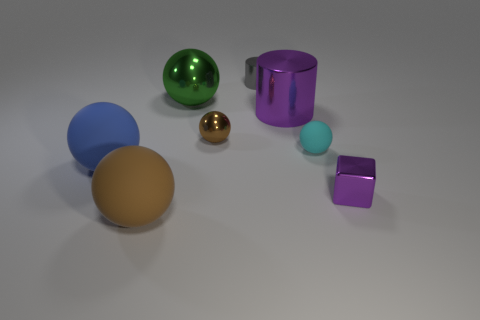How many big purple objects have the same shape as the cyan thing?
Offer a terse response. 0. The matte thing that is both behind the brown rubber sphere and left of the small brown shiny object is what color?
Your answer should be very brief. Blue. What number of cyan things are there?
Make the answer very short. 1. Does the block have the same size as the cyan matte object?
Offer a very short reply. Yes. Are there any other tiny shiny cylinders of the same color as the small metallic cylinder?
Your response must be concise. No. There is a purple thing that is behind the tiny purple shiny thing; is it the same shape as the green shiny object?
Provide a succinct answer. No. What number of shiny objects are the same size as the blue sphere?
Offer a very short reply. 2. There is a brown thing that is behind the cyan rubber thing; what number of large brown matte objects are right of it?
Provide a succinct answer. 0. Do the thing on the right side of the small cyan sphere and the large brown sphere have the same material?
Provide a short and direct response. No. Does the brown sphere that is to the right of the large brown sphere have the same material as the brown object in front of the cyan ball?
Your response must be concise. No. 